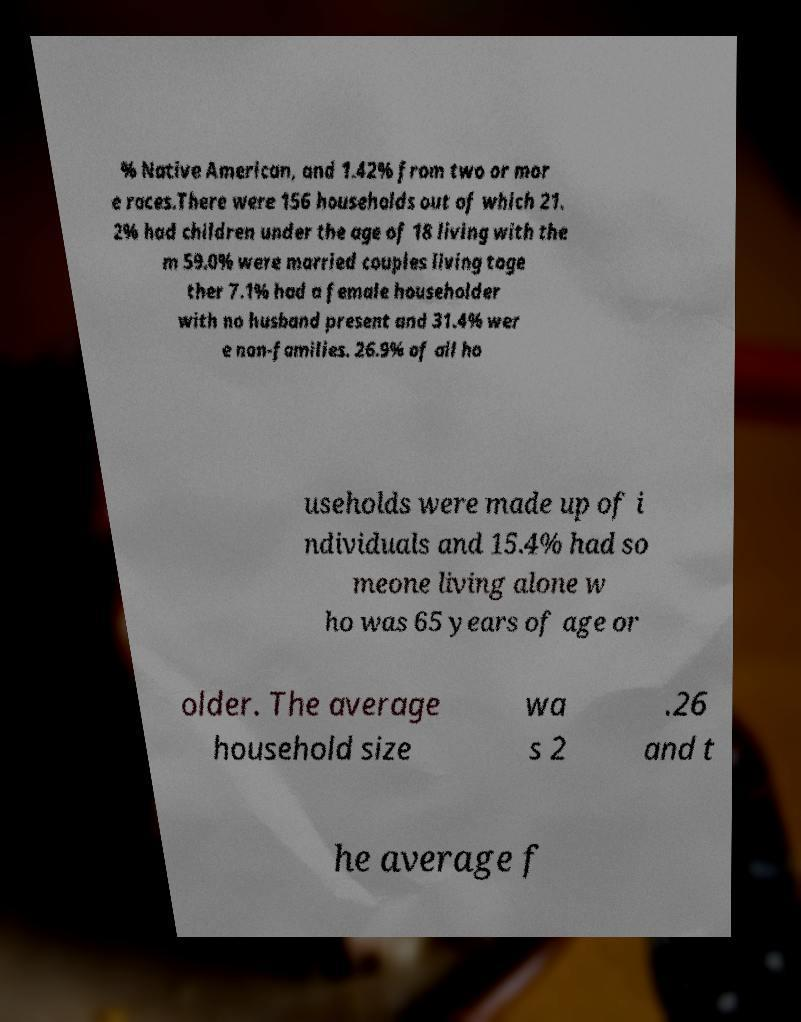Can you accurately transcribe the text from the provided image for me? % Native American, and 1.42% from two or mor e races.There were 156 households out of which 21. 2% had children under the age of 18 living with the m 59.0% were married couples living toge ther 7.1% had a female householder with no husband present and 31.4% wer e non-families. 26.9% of all ho useholds were made up of i ndividuals and 15.4% had so meone living alone w ho was 65 years of age or older. The average household size wa s 2 .26 and t he average f 